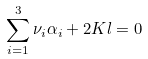Convert formula to latex. <formula><loc_0><loc_0><loc_500><loc_500>\sum _ { i = 1 } ^ { 3 } \nu _ { i } \alpha _ { i } + 2 K l = 0</formula> 